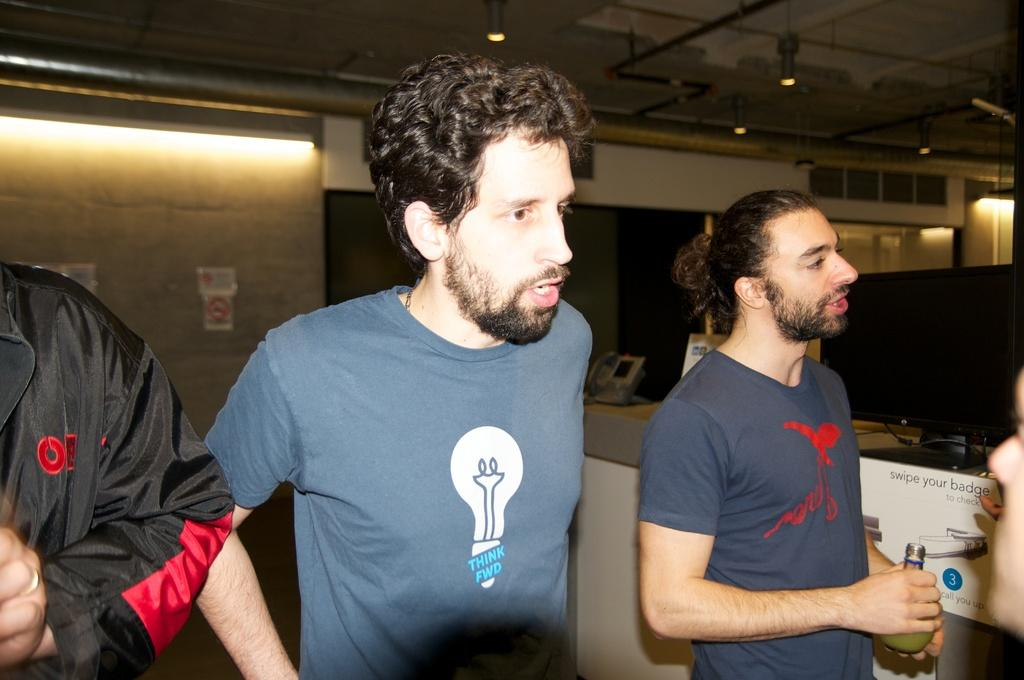<image>
Render a clear and concise summary of the photo. A bearded man wearing a blue shirt a light bulb logo that reads "THINK FWD" is talking to someone. 